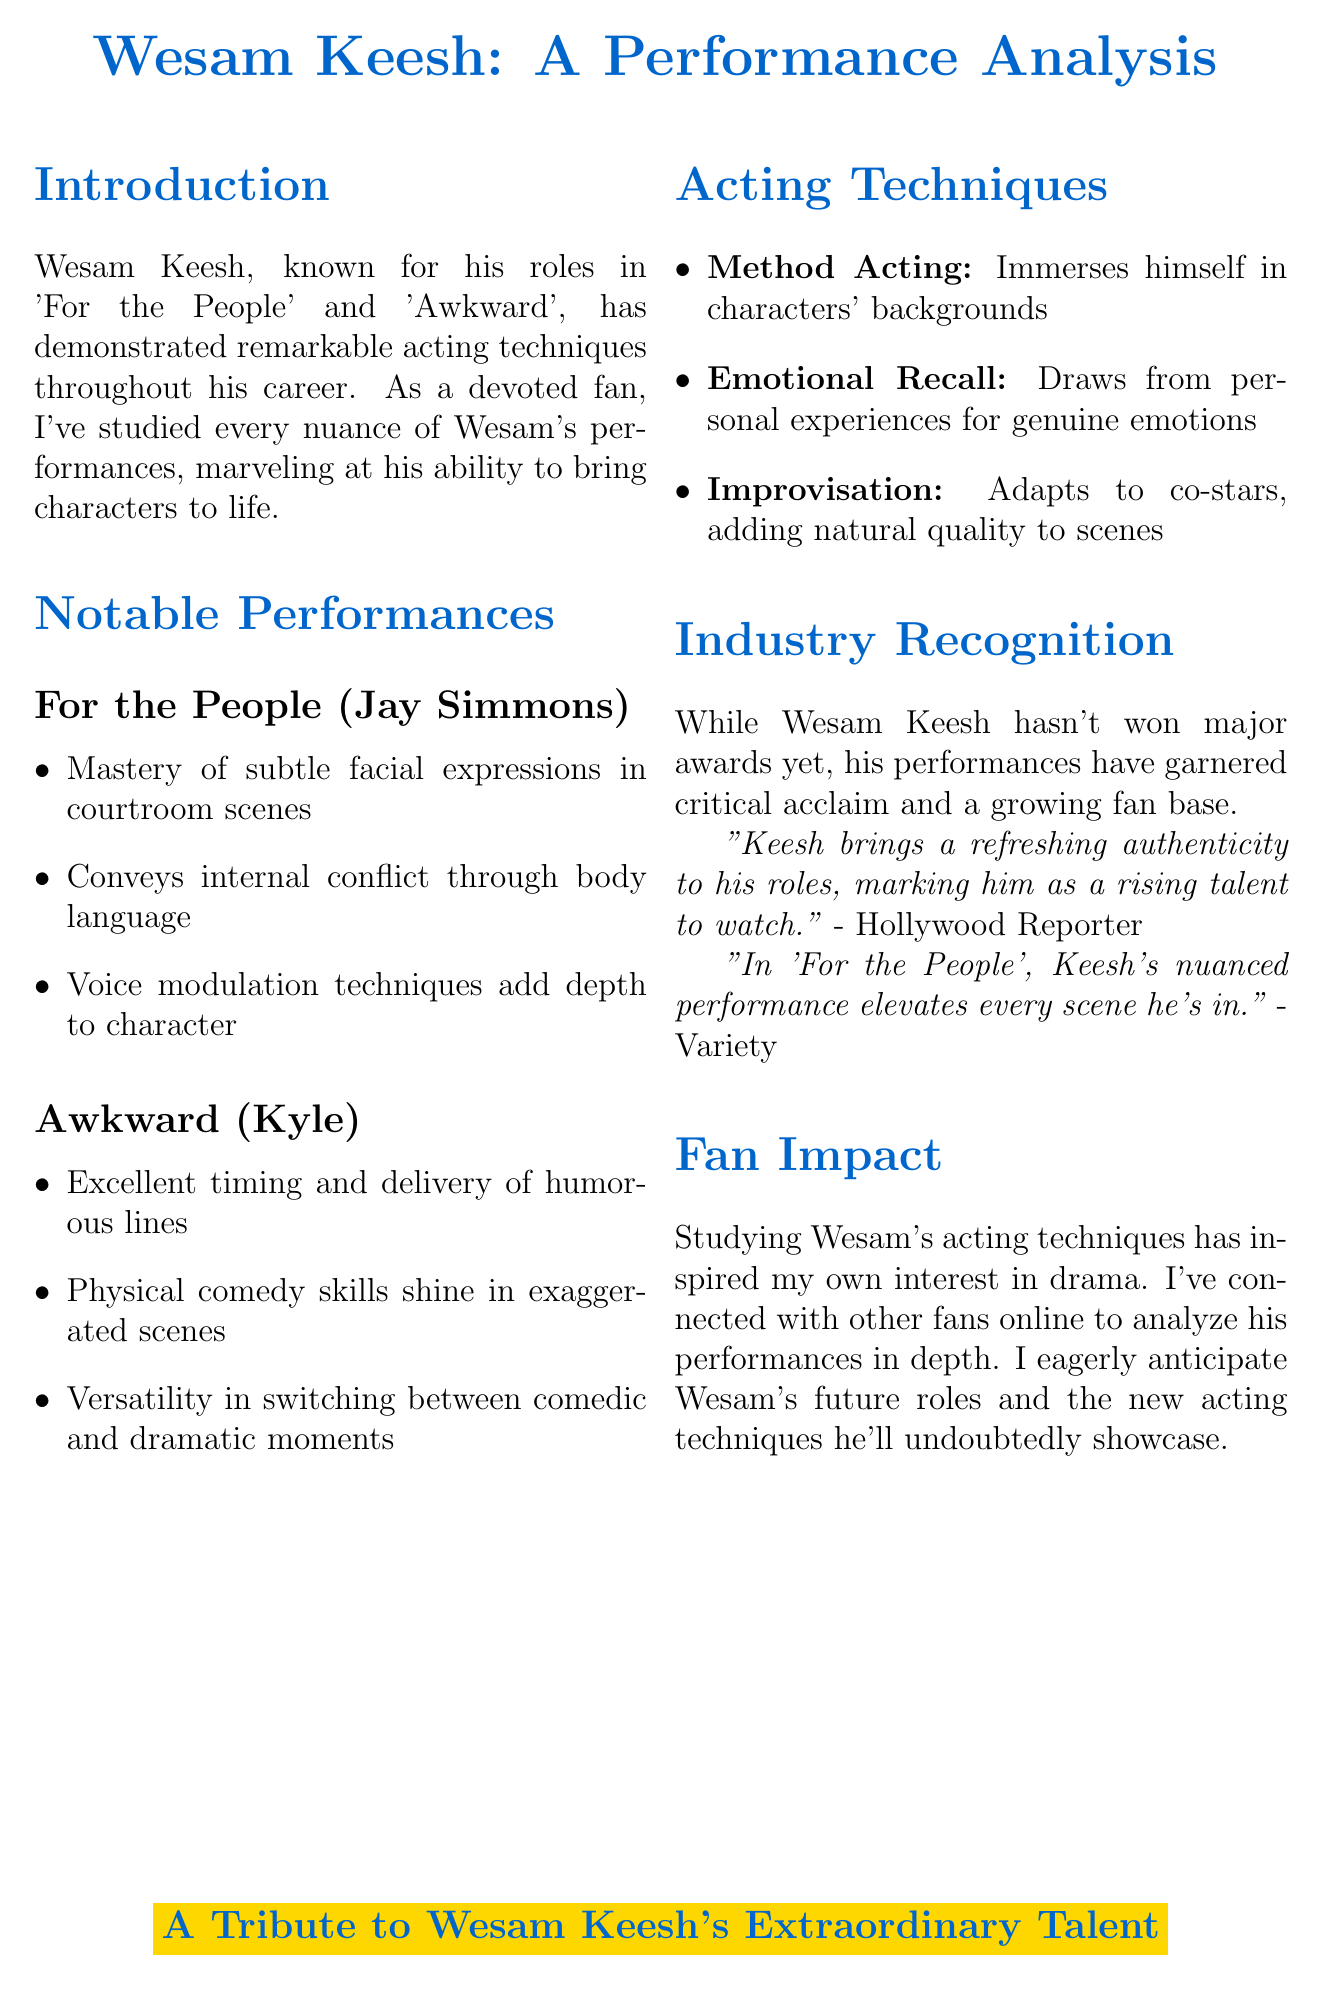What are Wesam Keesh's notable performances? The notable performances mentioned in the document are 'For the People' and 'Awkward'.
Answer: 'For the People', 'Awkward' Who did Wesam Keesh portray in 'For the People'? The document states that he portrayed the character Jay Simmons in 'For the People'.
Answer: Jay Simmons What technique does Wesam Keesh use that involves immersing himself in character backgrounds? The document lists this technique as Method Acting.
Answer: Method Acting Which performance showcases Wesam Keesh's physical comedy skills? The document mentions 'Awkward' as the performance highlighting his physical comedy skills.
Answer: Awkward What is the primary fan observation regarding Keesh's emotional recall technique? The document indicates that the fan observation is about the raw emotion he brings to his roles.
Answer: Raw emotion What has been one impact of Wesam Keesh's acting techniques on his fans? The document states that studying his techniques inspired the fan to pursue an interest in drama and performance art.
Answer: Inspired interest in drama Which publication described Keesh as a rising talent? According to the document, the Hollywood Reporter described him as a rising talent.
Answer: Hollywood Reporter What character did Wesam Keesh play in 'Awkward'? The document specifies that he played the character Kyle in 'Awkward'.
Answer: Kyle 